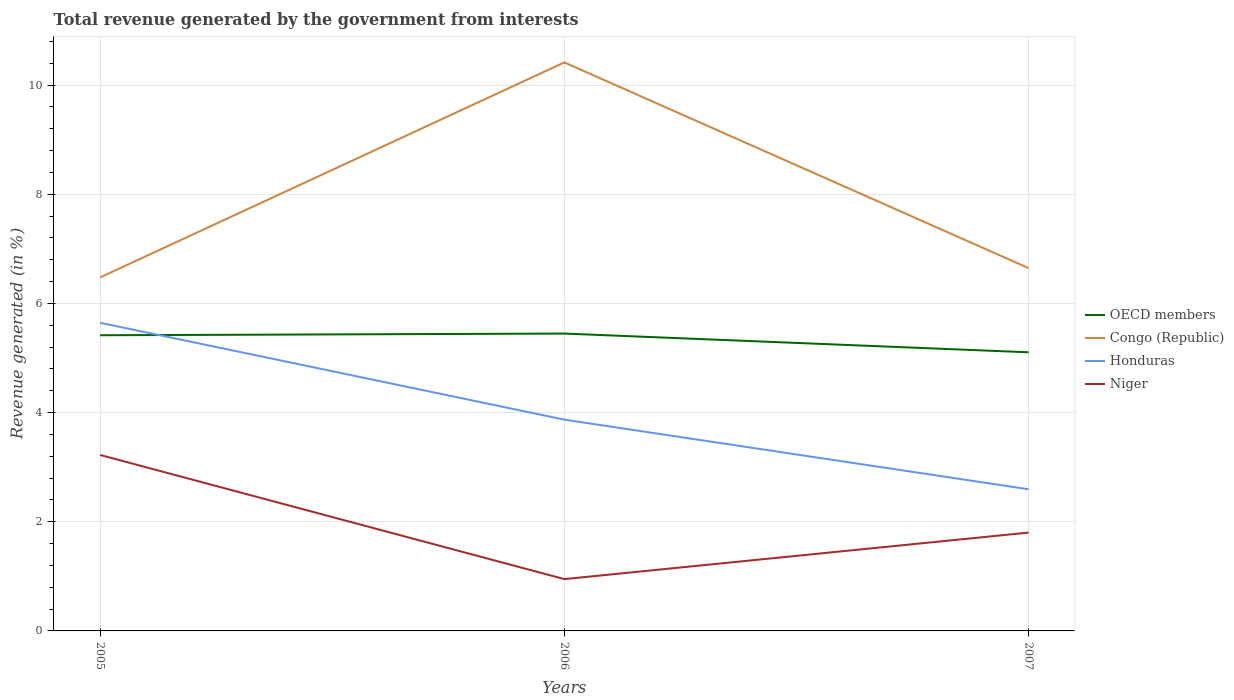How many different coloured lines are there?
Provide a succinct answer. 4. Across all years, what is the maximum total revenue generated in Niger?
Your answer should be compact. 0.95. In which year was the total revenue generated in Niger maximum?
Give a very brief answer. 2006. What is the total total revenue generated in Congo (Republic) in the graph?
Keep it short and to the point. -0.17. What is the difference between the highest and the second highest total revenue generated in OECD members?
Provide a short and direct response. 0.34. What is the difference between the highest and the lowest total revenue generated in Niger?
Your answer should be very brief. 1. Is the total revenue generated in OECD members strictly greater than the total revenue generated in Honduras over the years?
Give a very brief answer. No. How many lines are there?
Provide a short and direct response. 4. How many years are there in the graph?
Keep it short and to the point. 3. Does the graph contain any zero values?
Keep it short and to the point. No. How many legend labels are there?
Your response must be concise. 4. How are the legend labels stacked?
Your answer should be very brief. Vertical. What is the title of the graph?
Keep it short and to the point. Total revenue generated by the government from interests. What is the label or title of the Y-axis?
Give a very brief answer. Revenue generated (in %). What is the Revenue generated (in %) of OECD members in 2005?
Your answer should be very brief. 5.42. What is the Revenue generated (in %) in Congo (Republic) in 2005?
Your response must be concise. 6.48. What is the Revenue generated (in %) of Honduras in 2005?
Offer a very short reply. 5.64. What is the Revenue generated (in %) of Niger in 2005?
Provide a short and direct response. 3.22. What is the Revenue generated (in %) of OECD members in 2006?
Keep it short and to the point. 5.45. What is the Revenue generated (in %) of Congo (Republic) in 2006?
Make the answer very short. 10.41. What is the Revenue generated (in %) of Honduras in 2006?
Your answer should be compact. 3.87. What is the Revenue generated (in %) of Niger in 2006?
Your answer should be very brief. 0.95. What is the Revenue generated (in %) in OECD members in 2007?
Your response must be concise. 5.1. What is the Revenue generated (in %) of Congo (Republic) in 2007?
Offer a terse response. 6.65. What is the Revenue generated (in %) in Honduras in 2007?
Provide a succinct answer. 2.6. What is the Revenue generated (in %) of Niger in 2007?
Provide a succinct answer. 1.8. Across all years, what is the maximum Revenue generated (in %) of OECD members?
Your response must be concise. 5.45. Across all years, what is the maximum Revenue generated (in %) in Congo (Republic)?
Your answer should be very brief. 10.41. Across all years, what is the maximum Revenue generated (in %) of Honduras?
Offer a very short reply. 5.64. Across all years, what is the maximum Revenue generated (in %) of Niger?
Your answer should be very brief. 3.22. Across all years, what is the minimum Revenue generated (in %) of OECD members?
Offer a terse response. 5.1. Across all years, what is the minimum Revenue generated (in %) in Congo (Republic)?
Your answer should be compact. 6.48. Across all years, what is the minimum Revenue generated (in %) of Honduras?
Your answer should be compact. 2.6. Across all years, what is the minimum Revenue generated (in %) in Niger?
Your answer should be very brief. 0.95. What is the total Revenue generated (in %) in OECD members in the graph?
Ensure brevity in your answer.  15.97. What is the total Revenue generated (in %) of Congo (Republic) in the graph?
Your answer should be very brief. 23.54. What is the total Revenue generated (in %) in Honduras in the graph?
Give a very brief answer. 12.11. What is the total Revenue generated (in %) in Niger in the graph?
Your answer should be very brief. 5.97. What is the difference between the Revenue generated (in %) of OECD members in 2005 and that in 2006?
Offer a very short reply. -0.03. What is the difference between the Revenue generated (in %) in Congo (Republic) in 2005 and that in 2006?
Make the answer very short. -3.94. What is the difference between the Revenue generated (in %) in Honduras in 2005 and that in 2006?
Give a very brief answer. 1.77. What is the difference between the Revenue generated (in %) of Niger in 2005 and that in 2006?
Your response must be concise. 2.27. What is the difference between the Revenue generated (in %) in OECD members in 2005 and that in 2007?
Your answer should be very brief. 0.31. What is the difference between the Revenue generated (in %) of Congo (Republic) in 2005 and that in 2007?
Your response must be concise. -0.17. What is the difference between the Revenue generated (in %) in Honduras in 2005 and that in 2007?
Keep it short and to the point. 3.05. What is the difference between the Revenue generated (in %) of Niger in 2005 and that in 2007?
Provide a succinct answer. 1.42. What is the difference between the Revenue generated (in %) of OECD members in 2006 and that in 2007?
Your answer should be very brief. 0.34. What is the difference between the Revenue generated (in %) in Congo (Republic) in 2006 and that in 2007?
Make the answer very short. 3.77. What is the difference between the Revenue generated (in %) in Honduras in 2006 and that in 2007?
Make the answer very short. 1.28. What is the difference between the Revenue generated (in %) in Niger in 2006 and that in 2007?
Provide a short and direct response. -0.85. What is the difference between the Revenue generated (in %) in OECD members in 2005 and the Revenue generated (in %) in Congo (Republic) in 2006?
Your answer should be compact. -5. What is the difference between the Revenue generated (in %) in OECD members in 2005 and the Revenue generated (in %) in Honduras in 2006?
Provide a succinct answer. 1.55. What is the difference between the Revenue generated (in %) in OECD members in 2005 and the Revenue generated (in %) in Niger in 2006?
Provide a succinct answer. 4.47. What is the difference between the Revenue generated (in %) of Congo (Republic) in 2005 and the Revenue generated (in %) of Honduras in 2006?
Ensure brevity in your answer.  2.61. What is the difference between the Revenue generated (in %) in Congo (Republic) in 2005 and the Revenue generated (in %) in Niger in 2006?
Give a very brief answer. 5.53. What is the difference between the Revenue generated (in %) of Honduras in 2005 and the Revenue generated (in %) of Niger in 2006?
Provide a succinct answer. 4.7. What is the difference between the Revenue generated (in %) in OECD members in 2005 and the Revenue generated (in %) in Congo (Republic) in 2007?
Your answer should be very brief. -1.23. What is the difference between the Revenue generated (in %) in OECD members in 2005 and the Revenue generated (in %) in Honduras in 2007?
Give a very brief answer. 2.82. What is the difference between the Revenue generated (in %) of OECD members in 2005 and the Revenue generated (in %) of Niger in 2007?
Your answer should be very brief. 3.61. What is the difference between the Revenue generated (in %) in Congo (Republic) in 2005 and the Revenue generated (in %) in Honduras in 2007?
Offer a very short reply. 3.88. What is the difference between the Revenue generated (in %) in Congo (Republic) in 2005 and the Revenue generated (in %) in Niger in 2007?
Provide a succinct answer. 4.67. What is the difference between the Revenue generated (in %) of Honduras in 2005 and the Revenue generated (in %) of Niger in 2007?
Your response must be concise. 3.84. What is the difference between the Revenue generated (in %) of OECD members in 2006 and the Revenue generated (in %) of Congo (Republic) in 2007?
Give a very brief answer. -1.2. What is the difference between the Revenue generated (in %) in OECD members in 2006 and the Revenue generated (in %) in Honduras in 2007?
Offer a very short reply. 2.85. What is the difference between the Revenue generated (in %) of OECD members in 2006 and the Revenue generated (in %) of Niger in 2007?
Your answer should be compact. 3.65. What is the difference between the Revenue generated (in %) of Congo (Republic) in 2006 and the Revenue generated (in %) of Honduras in 2007?
Keep it short and to the point. 7.82. What is the difference between the Revenue generated (in %) of Congo (Republic) in 2006 and the Revenue generated (in %) of Niger in 2007?
Your response must be concise. 8.61. What is the difference between the Revenue generated (in %) in Honduras in 2006 and the Revenue generated (in %) in Niger in 2007?
Your answer should be compact. 2.07. What is the average Revenue generated (in %) in OECD members per year?
Offer a very short reply. 5.32. What is the average Revenue generated (in %) in Congo (Republic) per year?
Your answer should be very brief. 7.85. What is the average Revenue generated (in %) of Honduras per year?
Ensure brevity in your answer.  4.04. What is the average Revenue generated (in %) in Niger per year?
Your answer should be compact. 1.99. In the year 2005, what is the difference between the Revenue generated (in %) of OECD members and Revenue generated (in %) of Congo (Republic)?
Your answer should be very brief. -1.06. In the year 2005, what is the difference between the Revenue generated (in %) in OECD members and Revenue generated (in %) in Honduras?
Give a very brief answer. -0.23. In the year 2005, what is the difference between the Revenue generated (in %) of OECD members and Revenue generated (in %) of Niger?
Make the answer very short. 2.19. In the year 2005, what is the difference between the Revenue generated (in %) in Congo (Republic) and Revenue generated (in %) in Honduras?
Provide a short and direct response. 0.83. In the year 2005, what is the difference between the Revenue generated (in %) in Congo (Republic) and Revenue generated (in %) in Niger?
Make the answer very short. 3.25. In the year 2005, what is the difference between the Revenue generated (in %) of Honduras and Revenue generated (in %) of Niger?
Keep it short and to the point. 2.42. In the year 2006, what is the difference between the Revenue generated (in %) in OECD members and Revenue generated (in %) in Congo (Republic)?
Offer a very short reply. -4.97. In the year 2006, what is the difference between the Revenue generated (in %) in OECD members and Revenue generated (in %) in Honduras?
Offer a terse response. 1.58. In the year 2006, what is the difference between the Revenue generated (in %) of OECD members and Revenue generated (in %) of Niger?
Ensure brevity in your answer.  4.5. In the year 2006, what is the difference between the Revenue generated (in %) in Congo (Republic) and Revenue generated (in %) in Honduras?
Your response must be concise. 6.54. In the year 2006, what is the difference between the Revenue generated (in %) in Congo (Republic) and Revenue generated (in %) in Niger?
Offer a very short reply. 9.47. In the year 2006, what is the difference between the Revenue generated (in %) of Honduras and Revenue generated (in %) of Niger?
Offer a terse response. 2.92. In the year 2007, what is the difference between the Revenue generated (in %) in OECD members and Revenue generated (in %) in Congo (Republic)?
Keep it short and to the point. -1.54. In the year 2007, what is the difference between the Revenue generated (in %) in OECD members and Revenue generated (in %) in Honduras?
Your answer should be compact. 2.51. In the year 2007, what is the difference between the Revenue generated (in %) of OECD members and Revenue generated (in %) of Niger?
Offer a very short reply. 3.3. In the year 2007, what is the difference between the Revenue generated (in %) of Congo (Republic) and Revenue generated (in %) of Honduras?
Make the answer very short. 4.05. In the year 2007, what is the difference between the Revenue generated (in %) in Congo (Republic) and Revenue generated (in %) in Niger?
Ensure brevity in your answer.  4.85. In the year 2007, what is the difference between the Revenue generated (in %) of Honduras and Revenue generated (in %) of Niger?
Your answer should be compact. 0.79. What is the ratio of the Revenue generated (in %) of Congo (Republic) in 2005 to that in 2006?
Ensure brevity in your answer.  0.62. What is the ratio of the Revenue generated (in %) of Honduras in 2005 to that in 2006?
Ensure brevity in your answer.  1.46. What is the ratio of the Revenue generated (in %) in Niger in 2005 to that in 2006?
Offer a terse response. 3.4. What is the ratio of the Revenue generated (in %) in OECD members in 2005 to that in 2007?
Offer a very short reply. 1.06. What is the ratio of the Revenue generated (in %) of Congo (Republic) in 2005 to that in 2007?
Keep it short and to the point. 0.97. What is the ratio of the Revenue generated (in %) in Honduras in 2005 to that in 2007?
Your answer should be very brief. 2.18. What is the ratio of the Revenue generated (in %) in Niger in 2005 to that in 2007?
Your answer should be compact. 1.79. What is the ratio of the Revenue generated (in %) in OECD members in 2006 to that in 2007?
Make the answer very short. 1.07. What is the ratio of the Revenue generated (in %) of Congo (Republic) in 2006 to that in 2007?
Give a very brief answer. 1.57. What is the ratio of the Revenue generated (in %) in Honduras in 2006 to that in 2007?
Give a very brief answer. 1.49. What is the ratio of the Revenue generated (in %) in Niger in 2006 to that in 2007?
Give a very brief answer. 0.53. What is the difference between the highest and the second highest Revenue generated (in %) in OECD members?
Your answer should be compact. 0.03. What is the difference between the highest and the second highest Revenue generated (in %) of Congo (Republic)?
Your answer should be compact. 3.77. What is the difference between the highest and the second highest Revenue generated (in %) of Honduras?
Make the answer very short. 1.77. What is the difference between the highest and the second highest Revenue generated (in %) of Niger?
Your answer should be very brief. 1.42. What is the difference between the highest and the lowest Revenue generated (in %) of OECD members?
Keep it short and to the point. 0.34. What is the difference between the highest and the lowest Revenue generated (in %) in Congo (Republic)?
Ensure brevity in your answer.  3.94. What is the difference between the highest and the lowest Revenue generated (in %) of Honduras?
Provide a short and direct response. 3.05. What is the difference between the highest and the lowest Revenue generated (in %) of Niger?
Give a very brief answer. 2.27. 